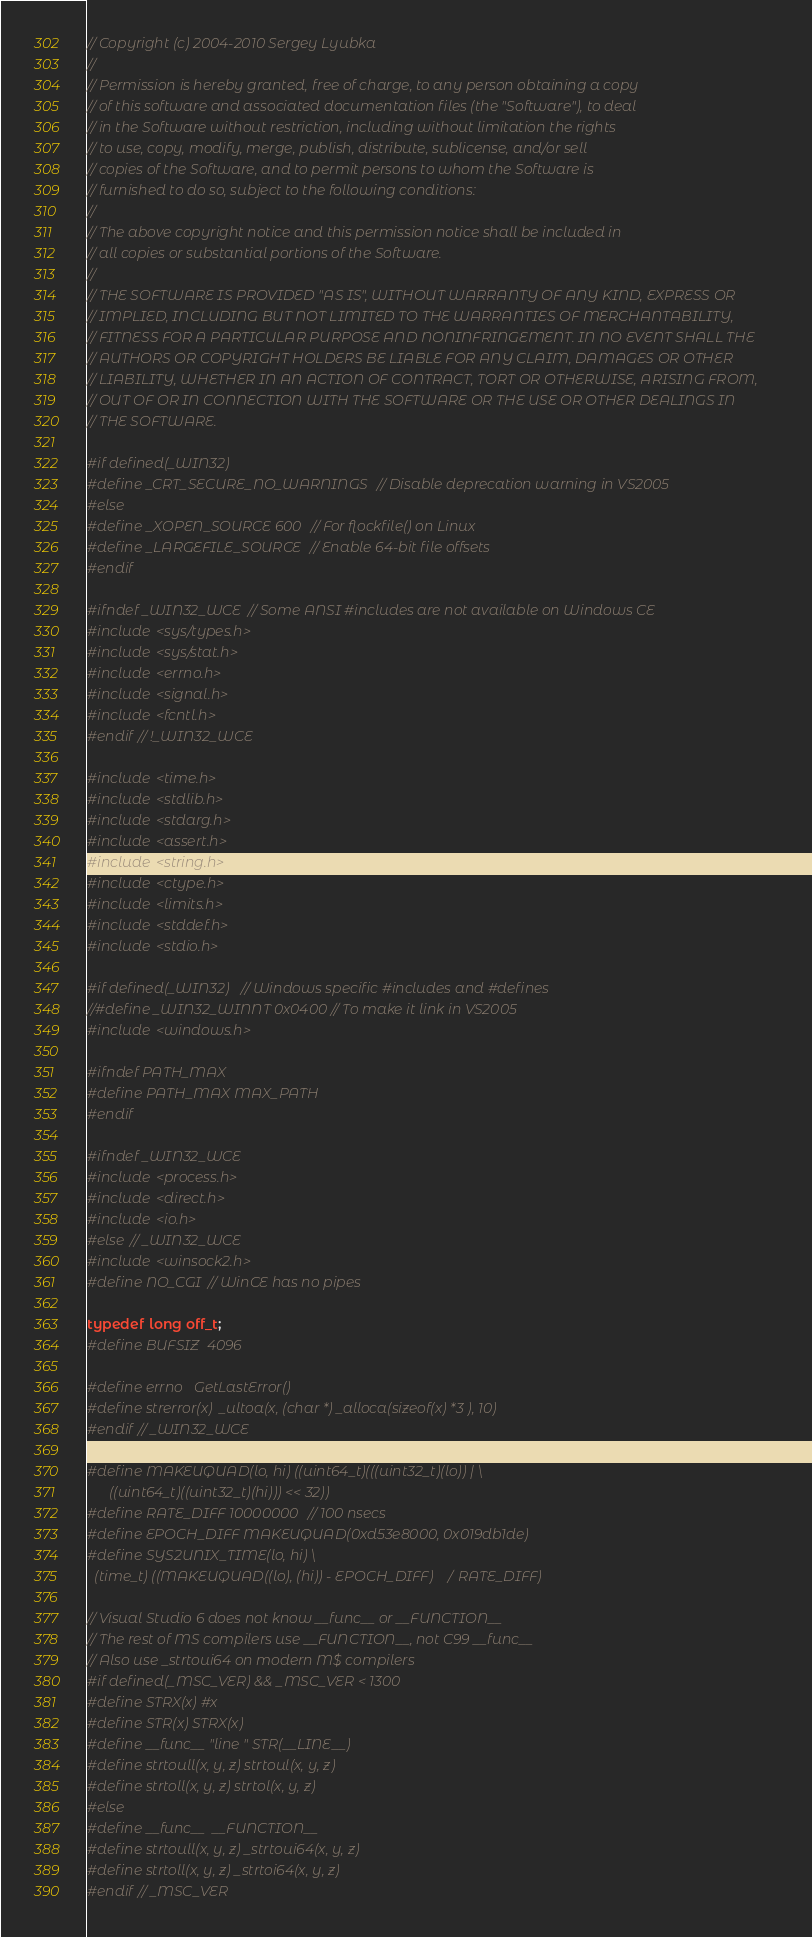Convert code to text. <code><loc_0><loc_0><loc_500><loc_500><_C_>// Copyright (c) 2004-2010 Sergey Lyubka
//
// Permission is hereby granted, free of charge, to any person obtaining a copy
// of this software and associated documentation files (the "Software"), to deal
// in the Software without restriction, including without limitation the rights
// to use, copy, modify, merge, publish, distribute, sublicense, and/or sell
// copies of the Software, and to permit persons to whom the Software is
// furnished to do so, subject to the following conditions:
//
// The above copyright notice and this permission notice shall be included in
// all copies or substantial portions of the Software.
//
// THE SOFTWARE IS PROVIDED "AS IS", WITHOUT WARRANTY OF ANY KIND, EXPRESS OR
// IMPLIED, INCLUDING BUT NOT LIMITED TO THE WARRANTIES OF MERCHANTABILITY,
// FITNESS FOR A PARTICULAR PURPOSE AND NONINFRINGEMENT. IN NO EVENT SHALL THE
// AUTHORS OR COPYRIGHT HOLDERS BE LIABLE FOR ANY CLAIM, DAMAGES OR OTHER
// LIABILITY, WHETHER IN AN ACTION OF CONTRACT, TORT OR OTHERWISE, ARISING FROM,
// OUT OF OR IN CONNECTION WITH THE SOFTWARE OR THE USE OR OTHER DEALINGS IN
// THE SOFTWARE.

#if defined(_WIN32)
#define _CRT_SECURE_NO_WARNINGS // Disable deprecation warning in VS2005
#else
#define _XOPEN_SOURCE 600 // For flockfile() on Linux
#define _LARGEFILE_SOURCE // Enable 64-bit file offsets
#endif

#ifndef _WIN32_WCE // Some ANSI #includes are not available on Windows CE
#include <sys/types.h>
#include <sys/stat.h>
#include <errno.h>
#include <signal.h>
#include <fcntl.h>
#endif // !_WIN32_WCE

#include <time.h>
#include <stdlib.h>
#include <stdarg.h>
#include <assert.h>
#include <string.h>
#include <ctype.h>
#include <limits.h>
#include <stddef.h>
#include <stdio.h>

#if defined(_WIN32)  // Windows specific #includes and #defines
//#define _WIN32_WINNT 0x0400 // To make it link in VS2005
#include <windows.h>

#ifndef PATH_MAX
#define PATH_MAX MAX_PATH
#endif

#ifndef _WIN32_WCE
#include <process.h>
#include <direct.h>
#include <io.h>
#else // _WIN32_WCE
#include <winsock2.h>
#define NO_CGI // WinCE has no pipes

typedef long off_t;
#define BUFSIZ  4096

#define errno   GetLastError()
#define strerror(x)  _ultoa(x, (char *) _alloca(sizeof(x) *3 ), 10)
#endif // _WIN32_WCE

#define MAKEUQUAD(lo, hi) ((uint64_t)(((uint32_t)(lo)) | \
      ((uint64_t)((uint32_t)(hi))) << 32))
#define RATE_DIFF 10000000 // 100 nsecs
#define EPOCH_DIFF MAKEUQUAD(0xd53e8000, 0x019db1de)
#define SYS2UNIX_TIME(lo, hi) \
  (time_t) ((MAKEUQUAD((lo), (hi)) - EPOCH_DIFF) / RATE_DIFF)

// Visual Studio 6 does not know __func__ or __FUNCTION__
// The rest of MS compilers use __FUNCTION__, not C99 __func__
// Also use _strtoui64 on modern M$ compilers
#if defined(_MSC_VER) && _MSC_VER < 1300
#define STRX(x) #x
#define STR(x) STRX(x)
#define __func__ "line " STR(__LINE__)
#define strtoull(x, y, z) strtoul(x, y, z)
#define strtoll(x, y, z) strtol(x, y, z)
#else
#define __func__  __FUNCTION__
#define strtoull(x, y, z) _strtoui64(x, y, z)
#define strtoll(x, y, z) _strtoi64(x, y, z)
#endif // _MSC_VER</code> 